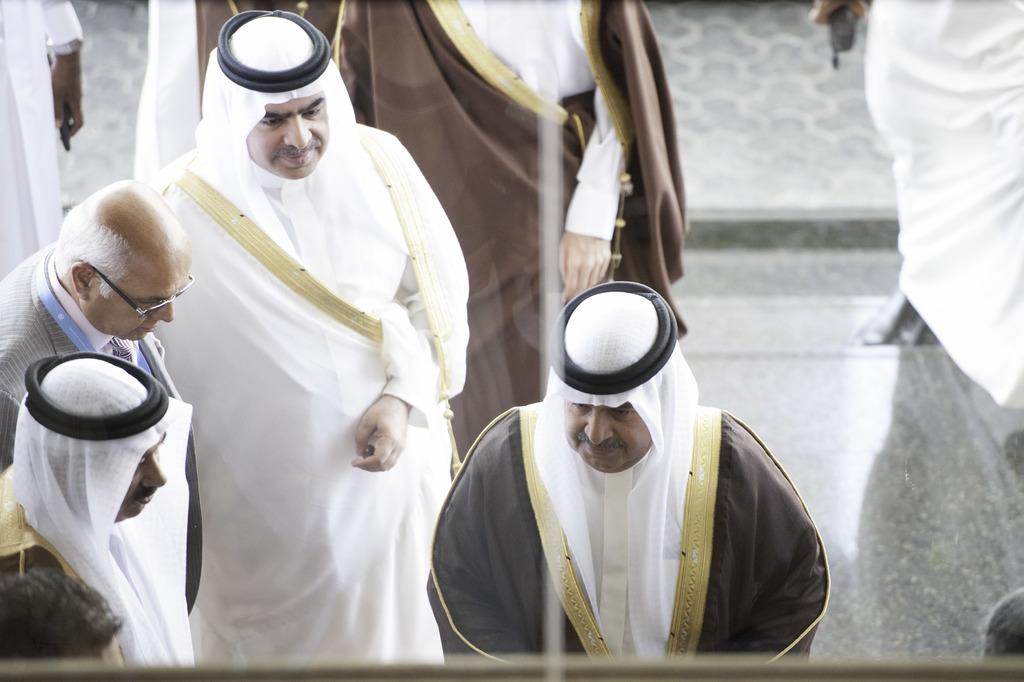How many people are in the image? There is a group of people in the image, but the exact number is not specified. What can be observed about the person in front of the group? The person in front of the group is wearing a white dress. What type of feather can be seen on the person wearing the white dress in the image? There is no mention of a feather on the person wearing the white dress in the image. 